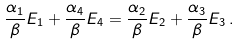<formula> <loc_0><loc_0><loc_500><loc_500>\frac { \alpha _ { 1 } } { \beta } E _ { 1 } + \frac { \alpha _ { 4 } } { \beta } E _ { 4 } = \frac { \alpha _ { 2 } } { \beta } E _ { 2 } + \frac { \alpha _ { 3 } } { \beta } E _ { 3 } \, .</formula> 